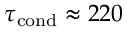<formula> <loc_0><loc_0><loc_500><loc_500>\tau _ { c o n d } \approx 2 2 0</formula> 